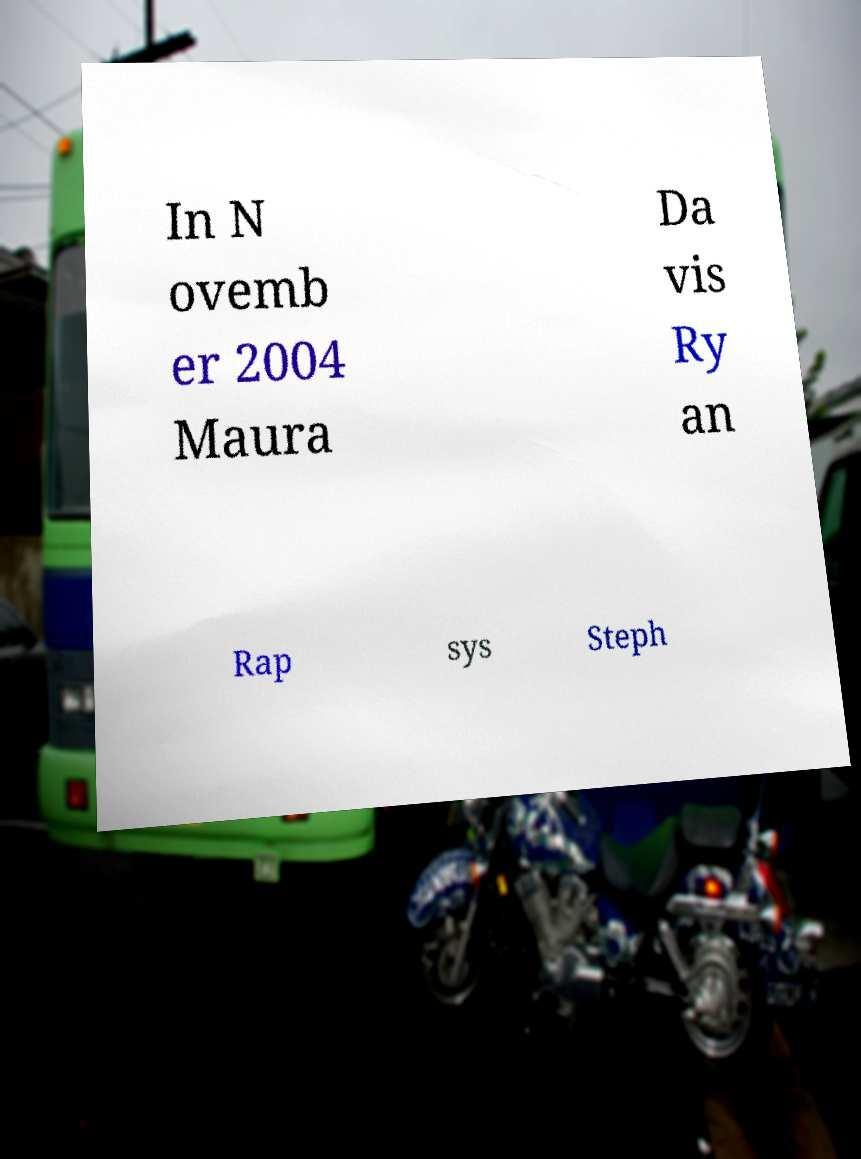There's text embedded in this image that I need extracted. Can you transcribe it verbatim? In N ovemb er 2004 Maura Da vis Ry an Rap sys Steph 